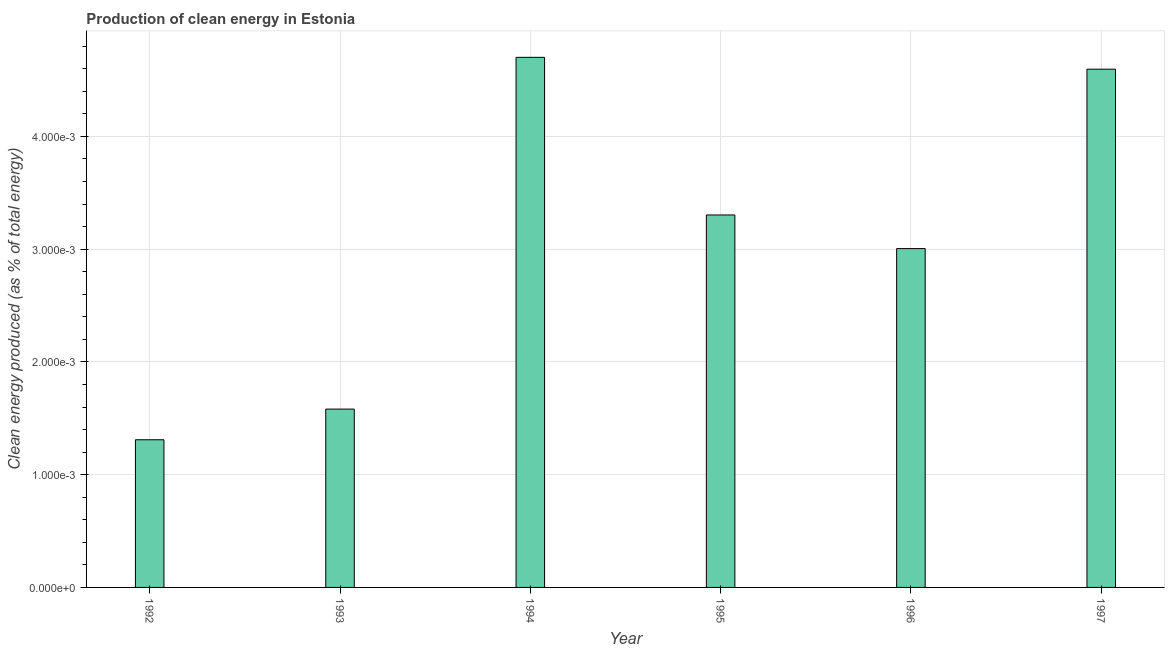Does the graph contain any zero values?
Ensure brevity in your answer.  No. Does the graph contain grids?
Provide a succinct answer. Yes. What is the title of the graph?
Provide a short and direct response. Production of clean energy in Estonia. What is the label or title of the X-axis?
Provide a succinct answer. Year. What is the label or title of the Y-axis?
Ensure brevity in your answer.  Clean energy produced (as % of total energy). What is the production of clean energy in 1996?
Keep it short and to the point. 0. Across all years, what is the maximum production of clean energy?
Ensure brevity in your answer.  0. Across all years, what is the minimum production of clean energy?
Provide a short and direct response. 0. In which year was the production of clean energy maximum?
Your response must be concise. 1994. In which year was the production of clean energy minimum?
Provide a succinct answer. 1992. What is the sum of the production of clean energy?
Provide a succinct answer. 0.02. What is the difference between the production of clean energy in 1992 and 1994?
Your answer should be very brief. -0. What is the average production of clean energy per year?
Make the answer very short. 0. What is the median production of clean energy?
Offer a terse response. 0. What is the ratio of the production of clean energy in 1992 to that in 1994?
Your response must be concise. 0.28. Is the difference between the production of clean energy in 1992 and 1997 greater than the difference between any two years?
Provide a short and direct response. No. Is the sum of the production of clean energy in 1993 and 1995 greater than the maximum production of clean energy across all years?
Offer a very short reply. Yes. What is the difference between the highest and the lowest production of clean energy?
Provide a succinct answer. 0. How many years are there in the graph?
Provide a succinct answer. 6. Are the values on the major ticks of Y-axis written in scientific E-notation?
Your response must be concise. Yes. What is the Clean energy produced (as % of total energy) in 1992?
Your answer should be compact. 0. What is the Clean energy produced (as % of total energy) of 1993?
Your answer should be very brief. 0. What is the Clean energy produced (as % of total energy) in 1994?
Offer a terse response. 0. What is the Clean energy produced (as % of total energy) in 1995?
Provide a succinct answer. 0. What is the Clean energy produced (as % of total energy) of 1996?
Ensure brevity in your answer.  0. What is the Clean energy produced (as % of total energy) in 1997?
Ensure brevity in your answer.  0. What is the difference between the Clean energy produced (as % of total energy) in 1992 and 1993?
Provide a short and direct response. -0. What is the difference between the Clean energy produced (as % of total energy) in 1992 and 1994?
Provide a succinct answer. -0. What is the difference between the Clean energy produced (as % of total energy) in 1992 and 1995?
Provide a short and direct response. -0. What is the difference between the Clean energy produced (as % of total energy) in 1992 and 1996?
Keep it short and to the point. -0. What is the difference between the Clean energy produced (as % of total energy) in 1992 and 1997?
Your response must be concise. -0. What is the difference between the Clean energy produced (as % of total energy) in 1993 and 1994?
Give a very brief answer. -0. What is the difference between the Clean energy produced (as % of total energy) in 1993 and 1995?
Make the answer very short. -0. What is the difference between the Clean energy produced (as % of total energy) in 1993 and 1996?
Provide a short and direct response. -0. What is the difference between the Clean energy produced (as % of total energy) in 1993 and 1997?
Your response must be concise. -0. What is the difference between the Clean energy produced (as % of total energy) in 1994 and 1995?
Give a very brief answer. 0. What is the difference between the Clean energy produced (as % of total energy) in 1994 and 1996?
Your answer should be compact. 0. What is the difference between the Clean energy produced (as % of total energy) in 1994 and 1997?
Offer a very short reply. 0. What is the difference between the Clean energy produced (as % of total energy) in 1995 and 1997?
Your response must be concise. -0. What is the difference between the Clean energy produced (as % of total energy) in 1996 and 1997?
Provide a succinct answer. -0. What is the ratio of the Clean energy produced (as % of total energy) in 1992 to that in 1993?
Make the answer very short. 0.83. What is the ratio of the Clean energy produced (as % of total energy) in 1992 to that in 1994?
Make the answer very short. 0.28. What is the ratio of the Clean energy produced (as % of total energy) in 1992 to that in 1995?
Provide a succinct answer. 0.4. What is the ratio of the Clean energy produced (as % of total energy) in 1992 to that in 1996?
Offer a very short reply. 0.44. What is the ratio of the Clean energy produced (as % of total energy) in 1992 to that in 1997?
Your answer should be very brief. 0.28. What is the ratio of the Clean energy produced (as % of total energy) in 1993 to that in 1994?
Your response must be concise. 0.34. What is the ratio of the Clean energy produced (as % of total energy) in 1993 to that in 1995?
Provide a succinct answer. 0.48. What is the ratio of the Clean energy produced (as % of total energy) in 1993 to that in 1996?
Your response must be concise. 0.53. What is the ratio of the Clean energy produced (as % of total energy) in 1993 to that in 1997?
Ensure brevity in your answer.  0.34. What is the ratio of the Clean energy produced (as % of total energy) in 1994 to that in 1995?
Your answer should be compact. 1.42. What is the ratio of the Clean energy produced (as % of total energy) in 1994 to that in 1996?
Give a very brief answer. 1.56. What is the ratio of the Clean energy produced (as % of total energy) in 1994 to that in 1997?
Offer a terse response. 1.02. What is the ratio of the Clean energy produced (as % of total energy) in 1995 to that in 1996?
Your answer should be very brief. 1.1. What is the ratio of the Clean energy produced (as % of total energy) in 1995 to that in 1997?
Offer a terse response. 0.72. What is the ratio of the Clean energy produced (as % of total energy) in 1996 to that in 1997?
Provide a succinct answer. 0.65. 